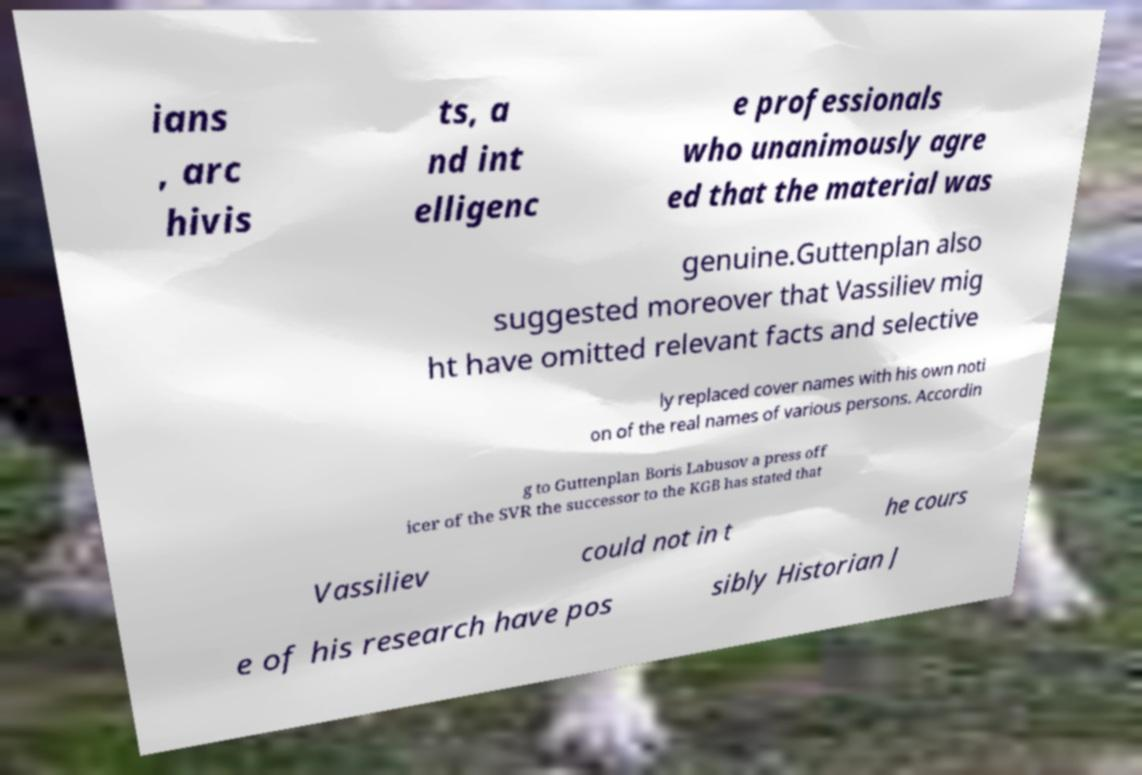What messages or text are displayed in this image? I need them in a readable, typed format. ians , arc hivis ts, a nd int elligenc e professionals who unanimously agre ed that the material was genuine.Guttenplan also suggested moreover that Vassiliev mig ht have omitted relevant facts and selective ly replaced cover names with his own noti on of the real names of various persons. Accordin g to Guttenplan Boris Labusov a press off icer of the SVR the successor to the KGB has stated that Vassiliev could not in t he cours e of his research have pos sibly Historian J 